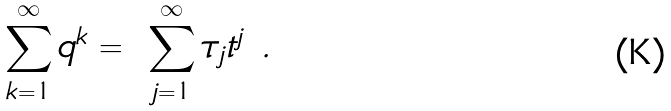Convert formula to latex. <formula><loc_0><loc_0><loc_500><loc_500>\sum _ { k = 1 } ^ { \infty } q ^ { k } = \ \sum _ { j = 1 } ^ { \infty } \tau _ { j } t ^ { j } \ .</formula> 